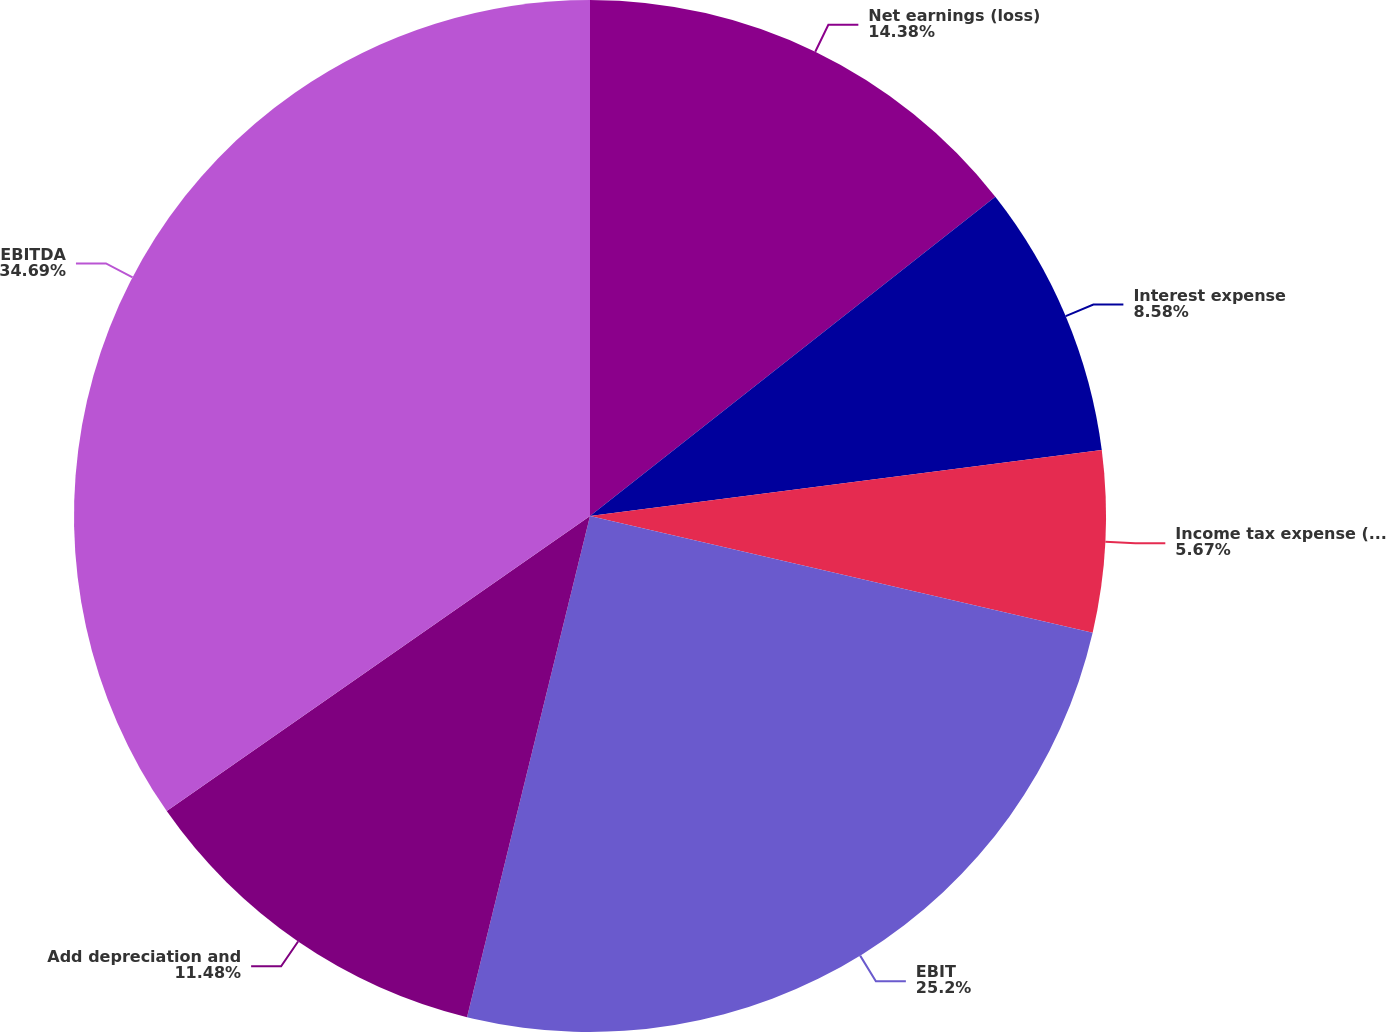Convert chart to OTSL. <chart><loc_0><loc_0><loc_500><loc_500><pie_chart><fcel>Net earnings (loss)<fcel>Interest expense<fcel>Income tax expense (benefit)<fcel>EBIT<fcel>Add depreciation and<fcel>EBITDA<nl><fcel>14.38%<fcel>8.58%<fcel>5.67%<fcel>25.2%<fcel>11.48%<fcel>34.69%<nl></chart> 